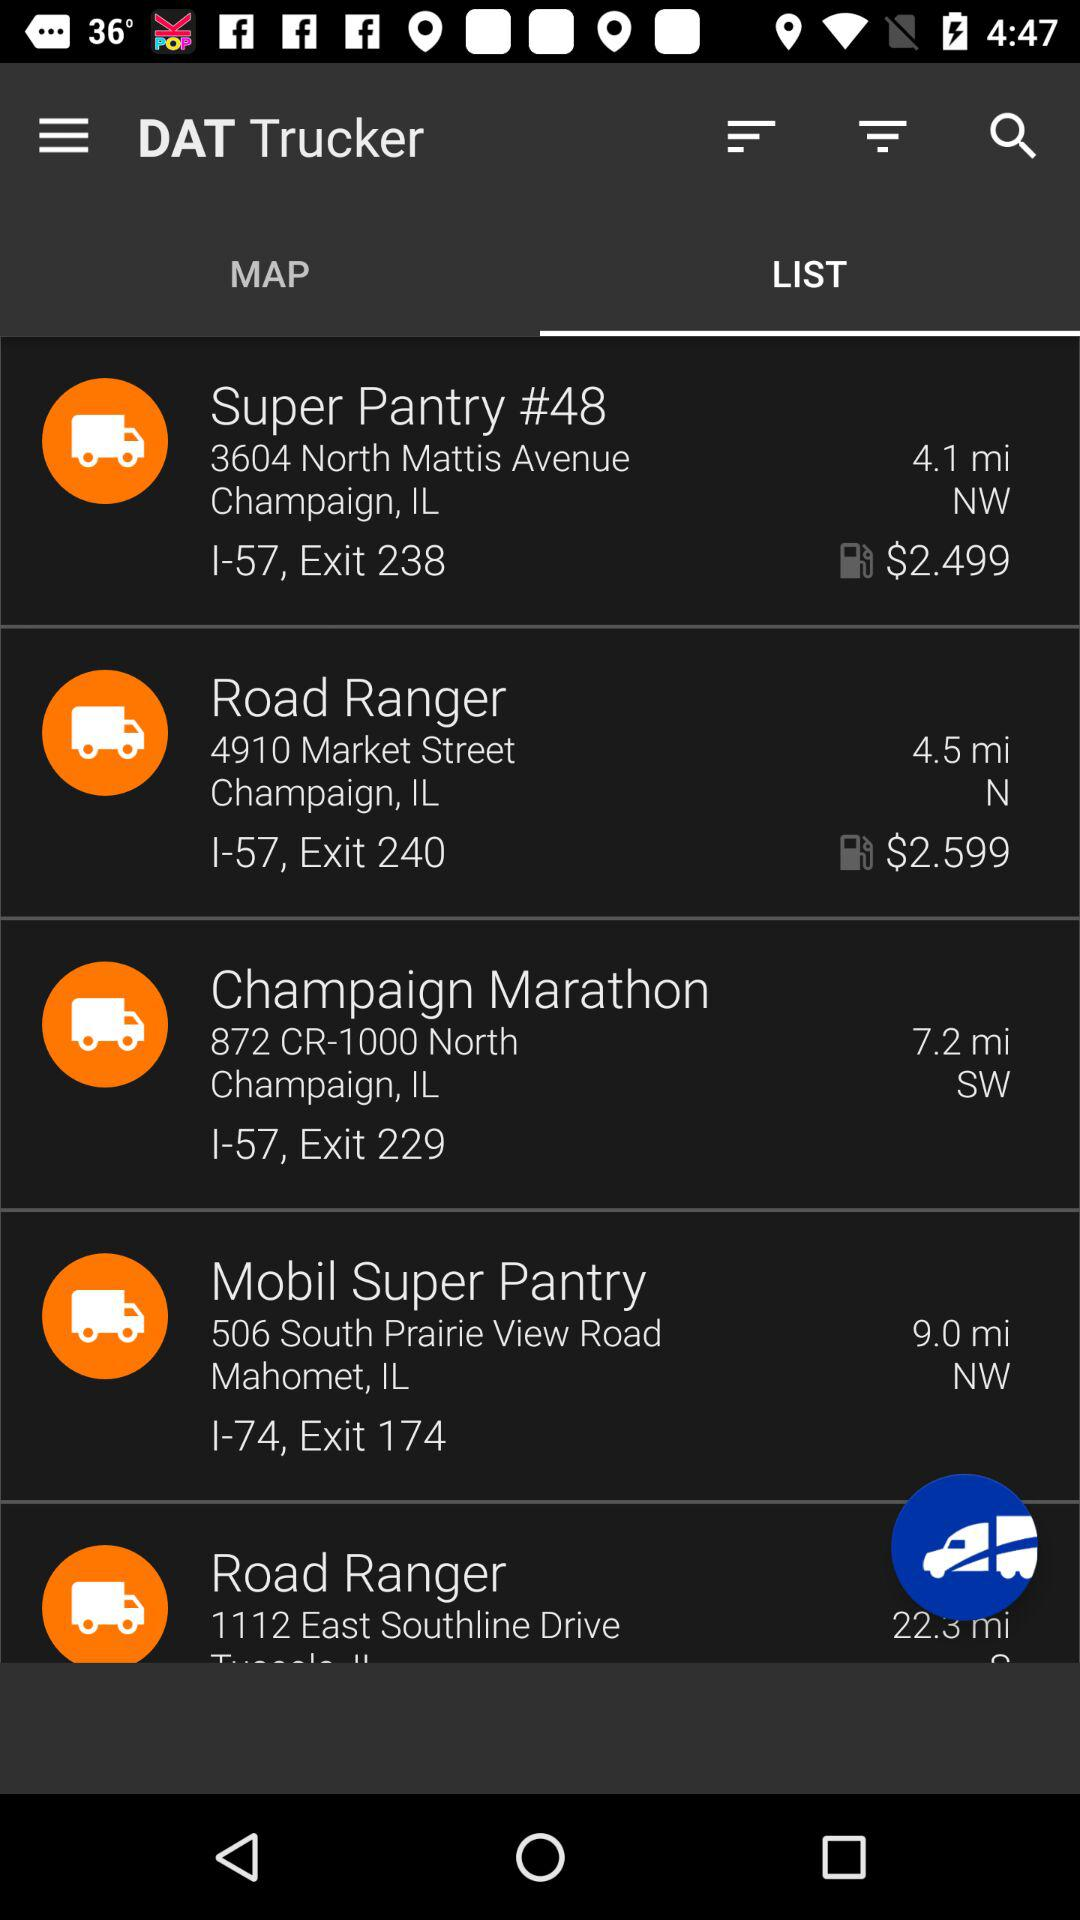What is the distance of Road Ranger, 4910 Market Street, Champaign, IL? The distance is 4.5 miles. 